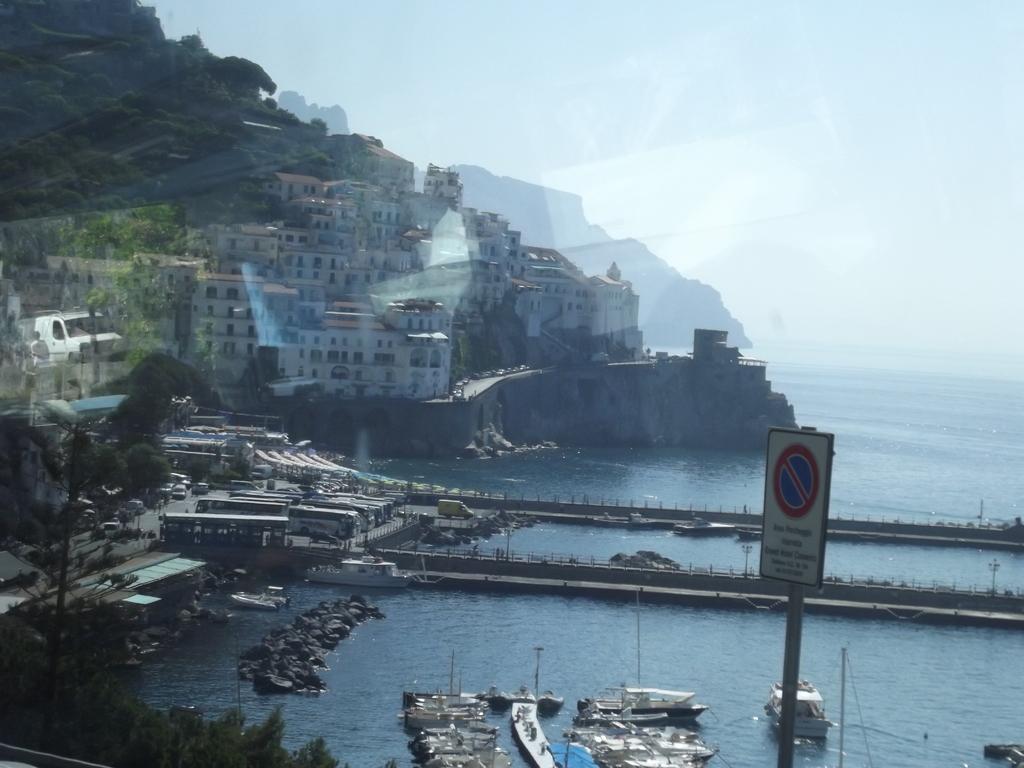Please provide a concise description of this image. There is a signboard attached to the pole. In the background, there are boats parked at the shipyard on the water, there are trees, buildings on the mountain and there are clouds in the sky. 